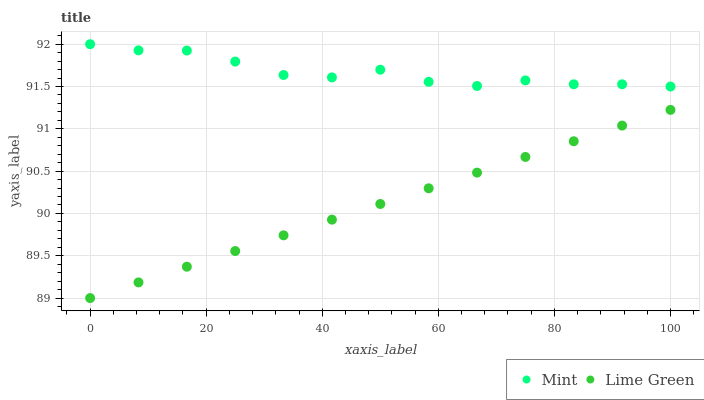Does Lime Green have the minimum area under the curve?
Answer yes or no. Yes. Does Mint have the maximum area under the curve?
Answer yes or no. Yes. Does Mint have the minimum area under the curve?
Answer yes or no. No. Is Lime Green the smoothest?
Answer yes or no. Yes. Is Mint the roughest?
Answer yes or no. Yes. Is Mint the smoothest?
Answer yes or no. No. Does Lime Green have the lowest value?
Answer yes or no. Yes. Does Mint have the lowest value?
Answer yes or no. No. Does Mint have the highest value?
Answer yes or no. Yes. Is Lime Green less than Mint?
Answer yes or no. Yes. Is Mint greater than Lime Green?
Answer yes or no. Yes. Does Lime Green intersect Mint?
Answer yes or no. No. 